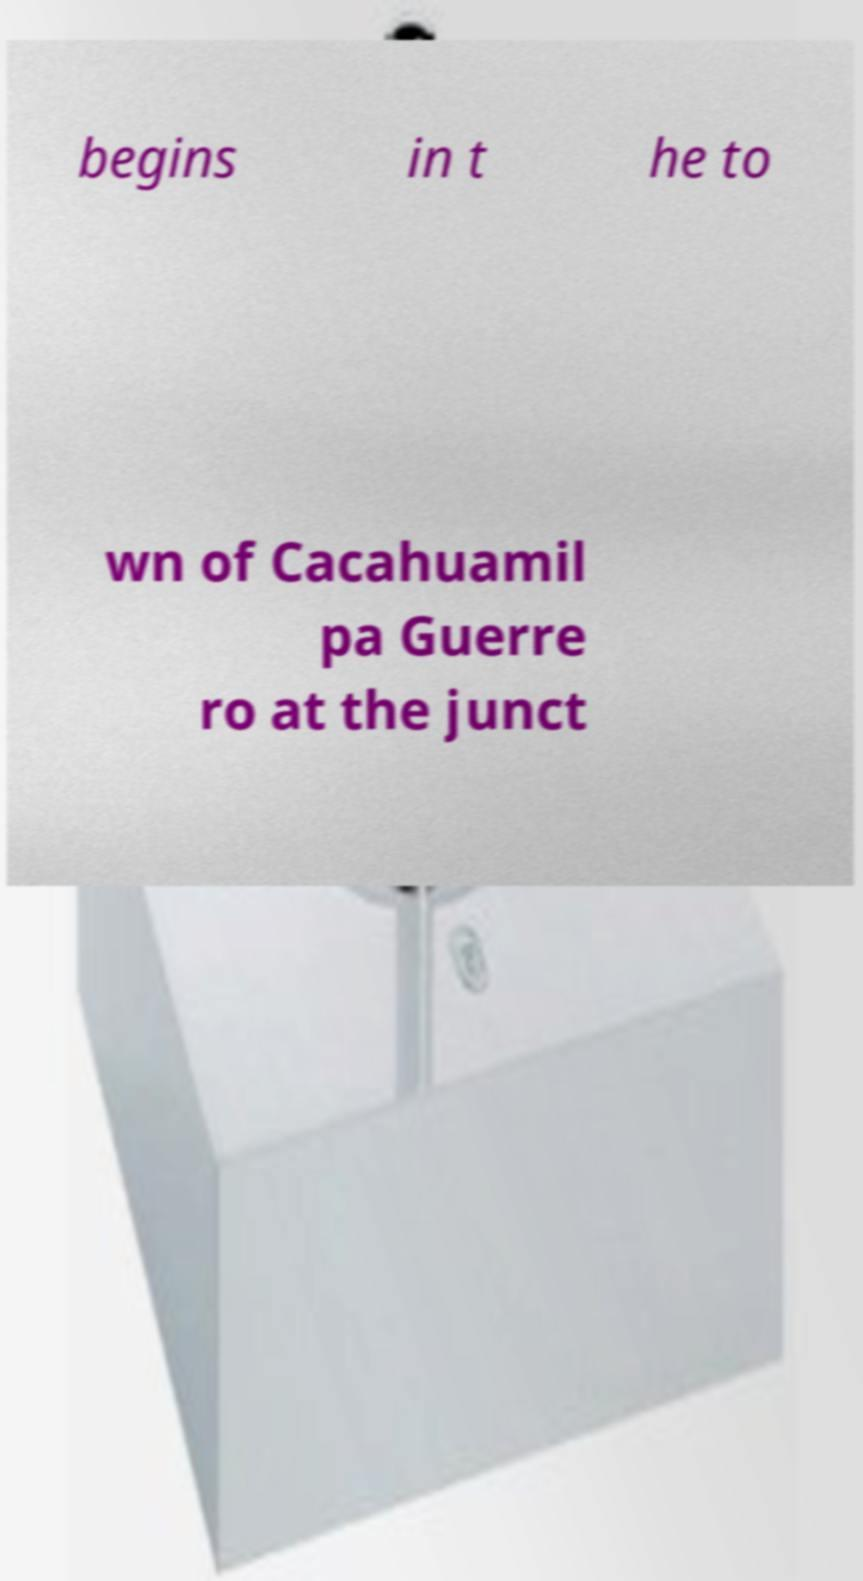Could you assist in decoding the text presented in this image and type it out clearly? begins in t he to wn of Cacahuamil pa Guerre ro at the junct 